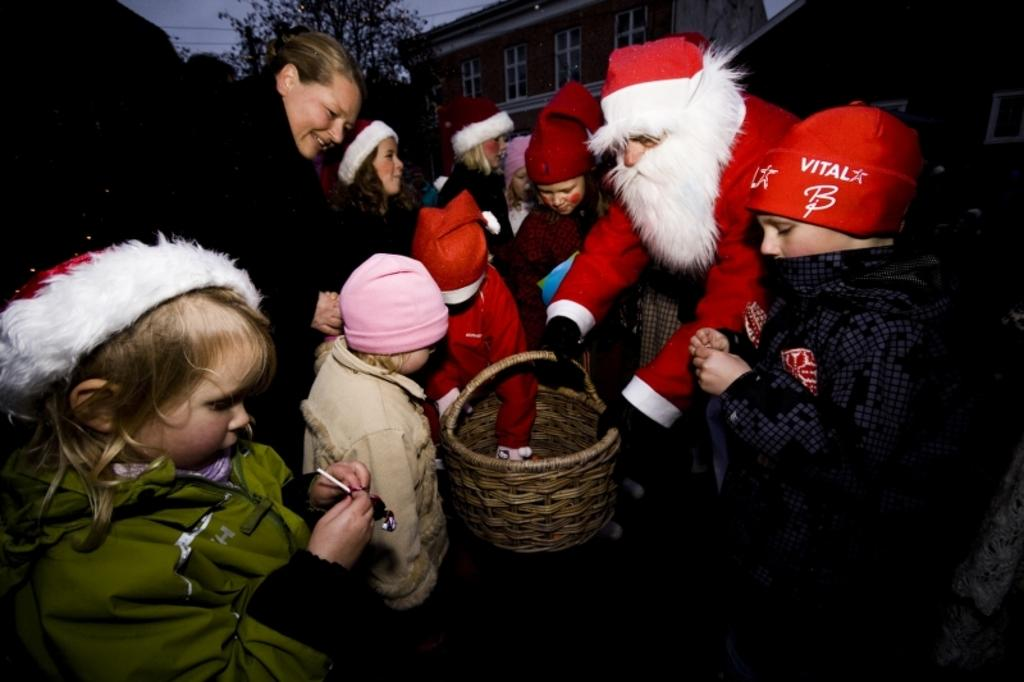What is happening in the image? There are people standing in the image. Can you describe what one of the people is holding? One of the people is holding a basket. What can be seen in the background of the image? There is a building and the sky visible in the background of the image. How many flowers are in the basket held by the person in the image? There is no information about flowers in the basket, as the facts only mention that one person is holding a basket. 